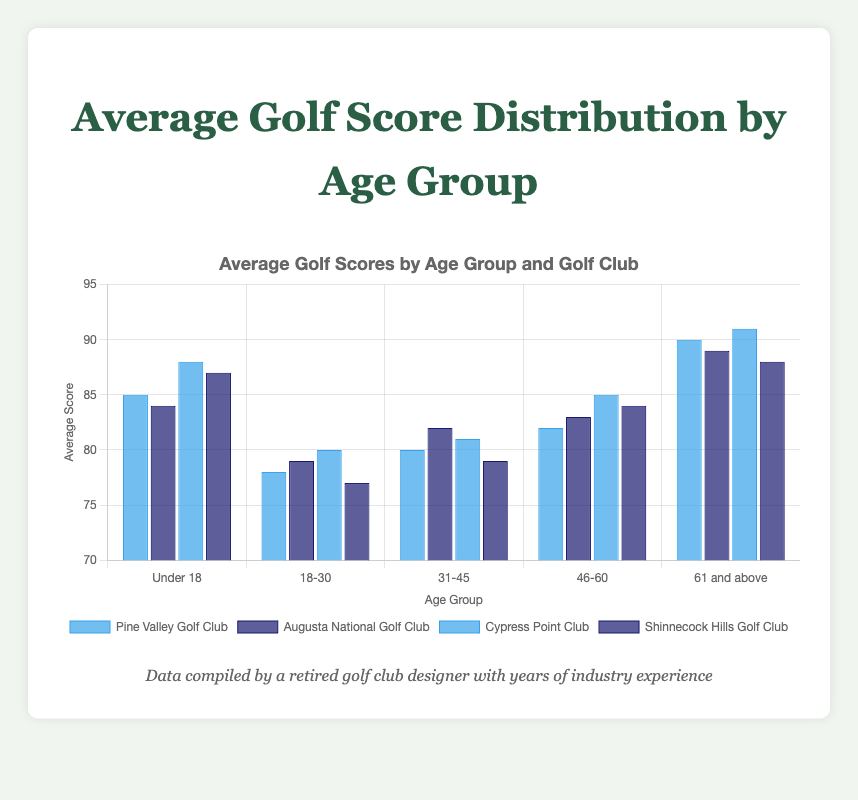Which age group has the highest average score at Cypress Point Club? To find this, look at the bar heights for each age group under the label "Cypress Point Club". The highest bar will indicate the highest average score. For "Under 18", the score is 88; for "18-30," it's 80; for "31-45," it's 81; for "46-60," it's 85; and for "61 and above," it's 91. The highest score is 91 under "61 and above".
Answer: 61 and above Between Pine Valley Golf Club and Shinnecock Hills Golf Club, which one has lower overall average scores for the 18-30 age group? Compare the bar heights for Pine Valley Golf Club and Shinnecock Hills Golf Club in the "18-30" age group. Pine Valley scores are 78, and Shinnecock Hills scores are 77. Shinnecock Hills Golf Club has the lower score
Answer: Shinnecock Hills Golf Club What is the average score of the 46-60 age group across all golf clubs? Each score for the 46-60 age group needs to be summed up and then divided by the count of the scores. The scores are 82 (Pine Valley), 83 (Augusta), 85 (Cypress Point), and 84 (Shinnecock Hills). Sum: 82 + 83 + 85 + 84 = 334. Average: 334 / 4 = 83.5
Answer: 83.5 Which golf club has the most consistent scores across all age groups? Consistent scores mean the score differences across age groups should be minimal. Pine Valley Golf Club's scores: (85-78-80-82-90) are most varied. Augusta National Golf Club's: (84-79-82-83-89) show less variation. Cypress Point Club's: (88-80-81-85-91) seem varied but not as much. Shinnecock Hills' (87-77-79-84-88) show more consistency with less abrupt changes.
Answer: Shinnecock Hills Golf Club For the "Under 18" age group, which golf club had the lowest average score and what is that score? Look at the bar heights under "Under 18". The lowest bar represents the lowest score. Scores are Pine Valley: 85, Augusta: 84, Cypress Point: 88, Shinnecock Hills: 87. Augusta National Golf Club has the lowest score of 84.
Answer: Augusta National Golf Club, 84 What is the difference in average scores between the "18-30" and "61 and above" age groups at Pine Valley Golf Club? Subtract the average score of the "18-30" age group from the "61 and above" age group at Pine Valley. Scores are 78 for "18-30" and 90 for "61 and above". Difference: 90 - 78 = 12
Answer: 12 Among the 31-45 age group, which golf club has the highest average score and what is that score? Look at the bar heights under "31-45" age group. The highest bar indicates the highest score. Scores are Pine Valley: 80, Augusta: 82, Cypress Point: 81, Shinnecock Hills: 79. Augusta National Golf Club has the highest score of 82.
Answer: Augusta National Golf Club, 82 